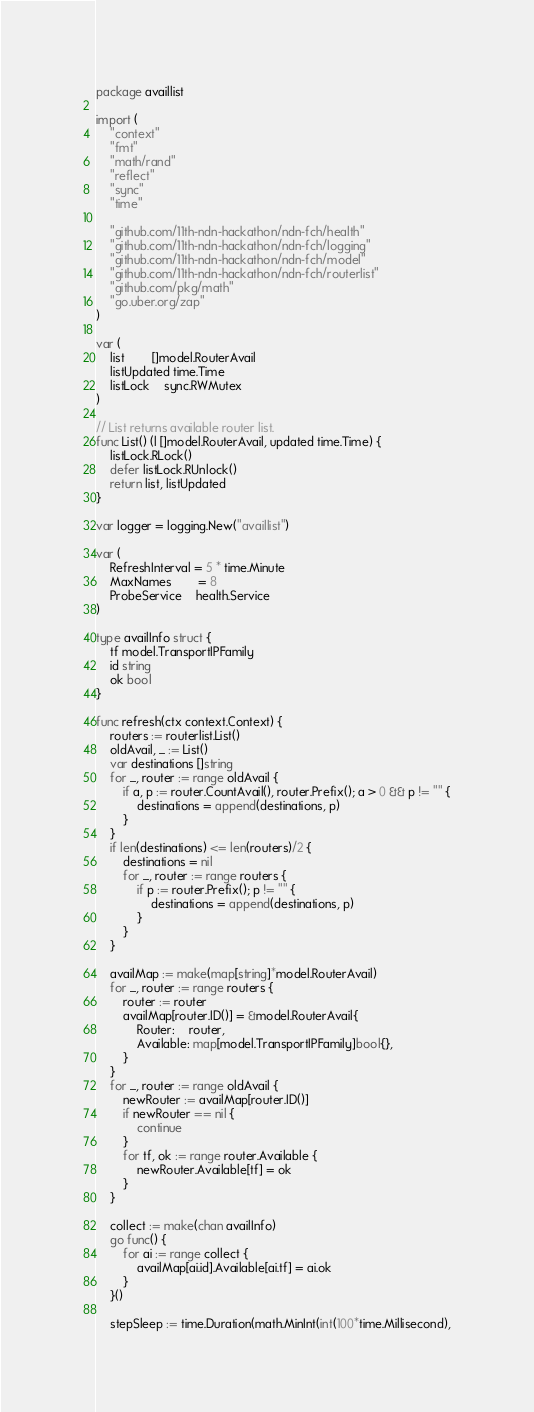Convert code to text. <code><loc_0><loc_0><loc_500><loc_500><_Go_>package availlist

import (
	"context"
	"fmt"
	"math/rand"
	"reflect"
	"sync"
	"time"

	"github.com/11th-ndn-hackathon/ndn-fch/health"
	"github.com/11th-ndn-hackathon/ndn-fch/logging"
	"github.com/11th-ndn-hackathon/ndn-fch/model"
	"github.com/11th-ndn-hackathon/ndn-fch/routerlist"
	"github.com/pkg/math"
	"go.uber.org/zap"
)

var (
	list        []model.RouterAvail
	listUpdated time.Time
	listLock    sync.RWMutex
)

// List returns available router list.
func List() (l []model.RouterAvail, updated time.Time) {
	listLock.RLock()
	defer listLock.RUnlock()
	return list, listUpdated
}

var logger = logging.New("availlist")

var (
	RefreshInterval = 5 * time.Minute
	MaxNames        = 8
	ProbeService    health.Service
)

type availInfo struct {
	tf model.TransportIPFamily
	id string
	ok bool
}

func refresh(ctx context.Context) {
	routers := routerlist.List()
	oldAvail, _ := List()
	var destinations []string
	for _, router := range oldAvail {
		if a, p := router.CountAvail(), router.Prefix(); a > 0 && p != "" {
			destinations = append(destinations, p)
		}
	}
	if len(destinations) <= len(routers)/2 {
		destinations = nil
		for _, router := range routers {
			if p := router.Prefix(); p != "" {
				destinations = append(destinations, p)
			}
		}
	}

	availMap := make(map[string]*model.RouterAvail)
	for _, router := range routers {
		router := router
		availMap[router.ID()] = &model.RouterAvail{
			Router:    router,
			Available: map[model.TransportIPFamily]bool{},
		}
	}
	for _, router := range oldAvail {
		newRouter := availMap[router.ID()]
		if newRouter == nil {
			continue
		}
		for tf, ok := range router.Available {
			newRouter.Available[tf] = ok
		}
	}

	collect := make(chan availInfo)
	go func() {
		for ai := range collect {
			availMap[ai.id].Available[ai.tf] = ai.ok
		}
	}()

	stepSleep := time.Duration(math.MinInt(int(100*time.Millisecond),</code> 